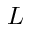Convert formula to latex. <formula><loc_0><loc_0><loc_500><loc_500>L</formula> 